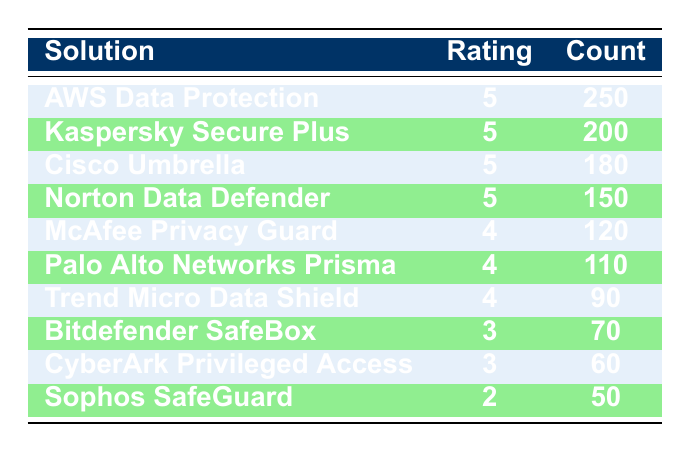What is the highest user feedback rating recorded for any solution? The table shows multiple solutions with a rating of 5. The highest rating is 5, which is recorded by AWS Data Protection, Kaspersky Secure Plus, Cisco Umbrella, and Norton Data Defender.
Answer: 5 Which solution received the lowest count of user feedback ratings? The solution with the lowest count is Sophos SafeGuard, which has a count of 50, as it has the lowest number in the 'Count' column.
Answer: Sophos SafeGuard What is the total count of user feedback ratings for solutions rated 5? Adding the counts for solutions rated 5 (AWS Data Protection, Kaspersky Secure Plus, Cisco Umbrella, Norton Data Defender) gives us 250 + 200 + 180 + 150 = 780. This makes the total count for ratings of 5 equal to 780.
Answer: 780 Is there any solution that received a feedback rating of 2? Yes, Sophos SafeGuard received a feedback rating of 2, as indicated in the table under the ratings column.
Answer: Yes What is the average count of user feedback ratings for solutions rated 4? The solutions rated 4 are McAfee Privacy Guard (120), Palo Alto Networks Prisma (110), and Trend Micro Data Shield (90). Adding these counts gives 120 + 110 + 90 = 320, and dividing this total by the number of solutions (3) gives us 320 / 3 = approximately 106.67.
Answer: 106.67 How many solutions have a feedback rating of 3, and what are their counts? There are two solutions with a rating of 3: Bitdefender SafeBox with a count of 70 and CyberArk Privileged Access with a count of 60.
Answer: 2 solutions; counts are 70 and 60 What is the sum of counts for solutions rated 3 and 4? The counts for ratings 3 are 70 (Bitdefender SafeBox) and 60 (CyberArk Privileged Access), totaling 130. The counts for ratings 4 are 120 (McAfee Privacy Guard), 110 (Palo Alto Networks Prisma), and 90 (Trend Micro Data Shield), which together add up to 320. The total sum is 130 + 320 = 450.
Answer: 450 Which solution has a higher count: Kaspersky Secure Plus or Trend Micro Data Shield? Kaspersky Secure Plus has a count of 200, while Trend Micro Data Shield has a count of 90. Comparing these, Kaspersky Secure Plus has the higher count.
Answer: Kaspersky Secure Plus How many more counts did AWS Data Protection receive compared to the lowest-rated solution? AWS Data Protection received a count of 250, while Sophos SafeGuard, which received the lowest rating, has a count of 50. The difference is 250 - 50 = 200.
Answer: 200 